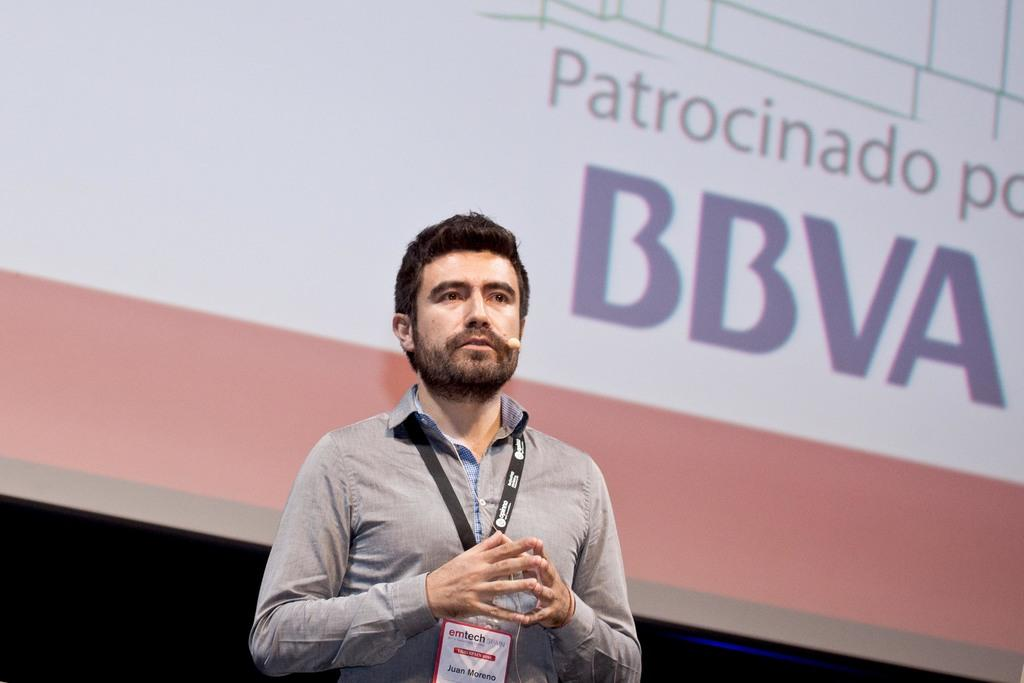<image>
Provide a brief description of the given image. a man stands in front of a screen with the acronym BBVA 